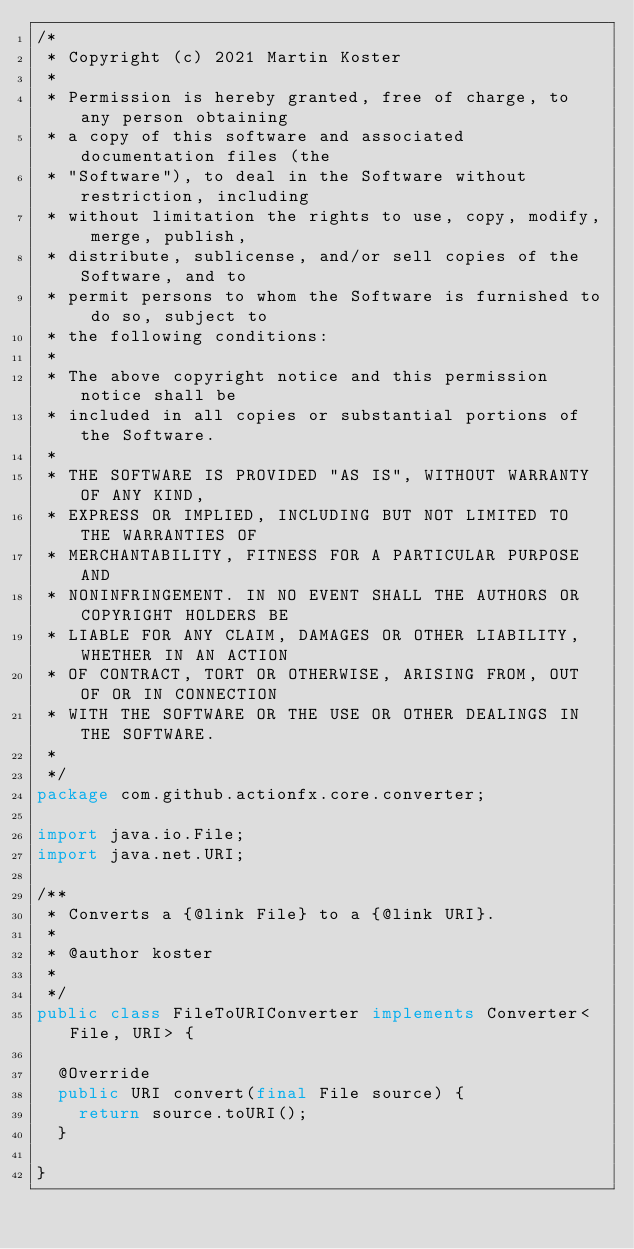Convert code to text. <code><loc_0><loc_0><loc_500><loc_500><_Java_>/*
 * Copyright (c) 2021 Martin Koster
 *
 * Permission is hereby granted, free of charge, to any person obtaining
 * a copy of this software and associated documentation files (the
 * "Software"), to deal in the Software without restriction, including
 * without limitation the rights to use, copy, modify, merge, publish,
 * distribute, sublicense, and/or sell copies of the Software, and to
 * permit persons to whom the Software is furnished to do so, subject to
 * the following conditions:
 *
 * The above copyright notice and this permission notice shall be
 * included in all copies or substantial portions of the Software.
 *
 * THE SOFTWARE IS PROVIDED "AS IS", WITHOUT WARRANTY OF ANY KIND,
 * EXPRESS OR IMPLIED, INCLUDING BUT NOT LIMITED TO THE WARRANTIES OF
 * MERCHANTABILITY, FITNESS FOR A PARTICULAR PURPOSE AND
 * NONINFRINGEMENT. IN NO EVENT SHALL THE AUTHORS OR COPYRIGHT HOLDERS BE
 * LIABLE FOR ANY CLAIM, DAMAGES OR OTHER LIABILITY, WHETHER IN AN ACTION
 * OF CONTRACT, TORT OR OTHERWISE, ARISING FROM, OUT OF OR IN CONNECTION
 * WITH THE SOFTWARE OR THE USE OR OTHER DEALINGS IN THE SOFTWARE.
 *
 */
package com.github.actionfx.core.converter;

import java.io.File;
import java.net.URI;

/**
 * Converts a {@link File} to a {@link URI}.
 *
 * @author koster
 *
 */
public class FileToURIConverter implements Converter<File, URI> {

	@Override
	public URI convert(final File source) {
		return source.toURI();
	}

}
</code> 